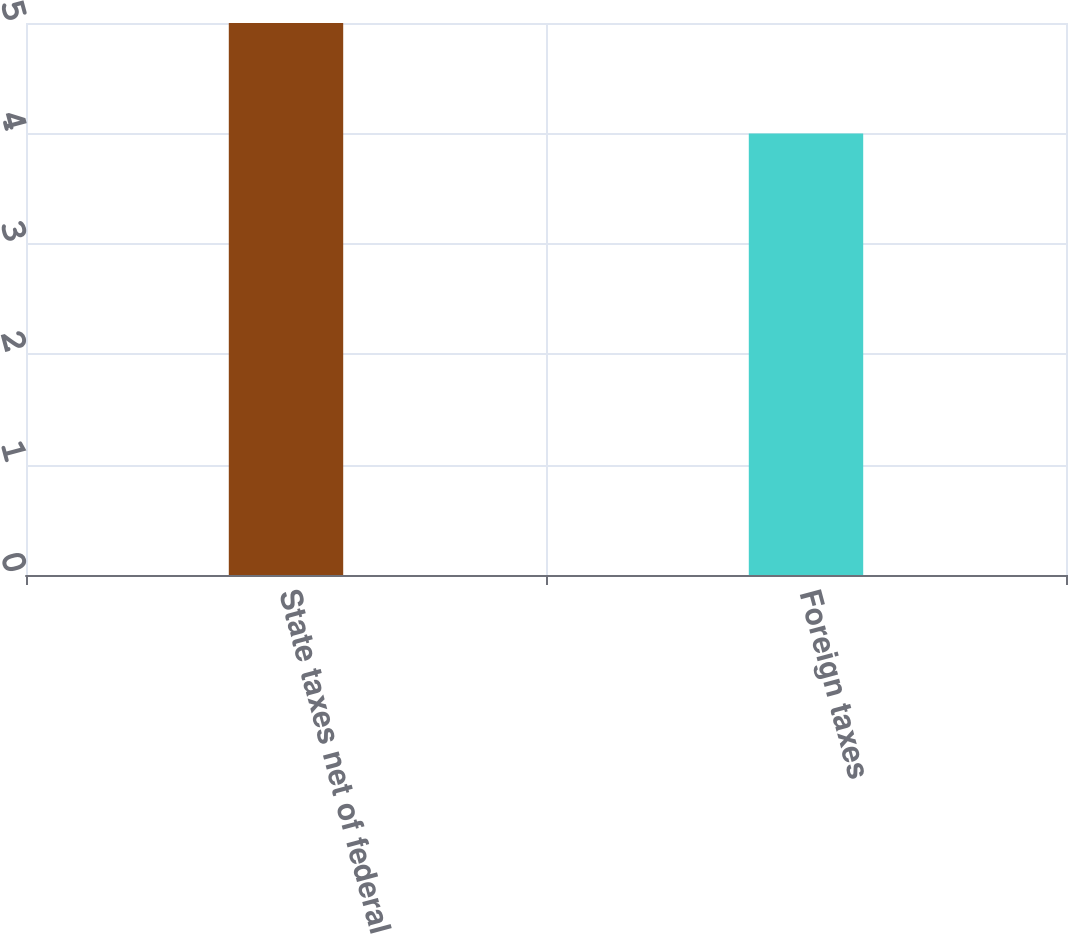<chart> <loc_0><loc_0><loc_500><loc_500><bar_chart><fcel>State taxes net of federal<fcel>Foreign taxes<nl><fcel>5<fcel>4<nl></chart> 